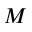<formula> <loc_0><loc_0><loc_500><loc_500>M</formula> 